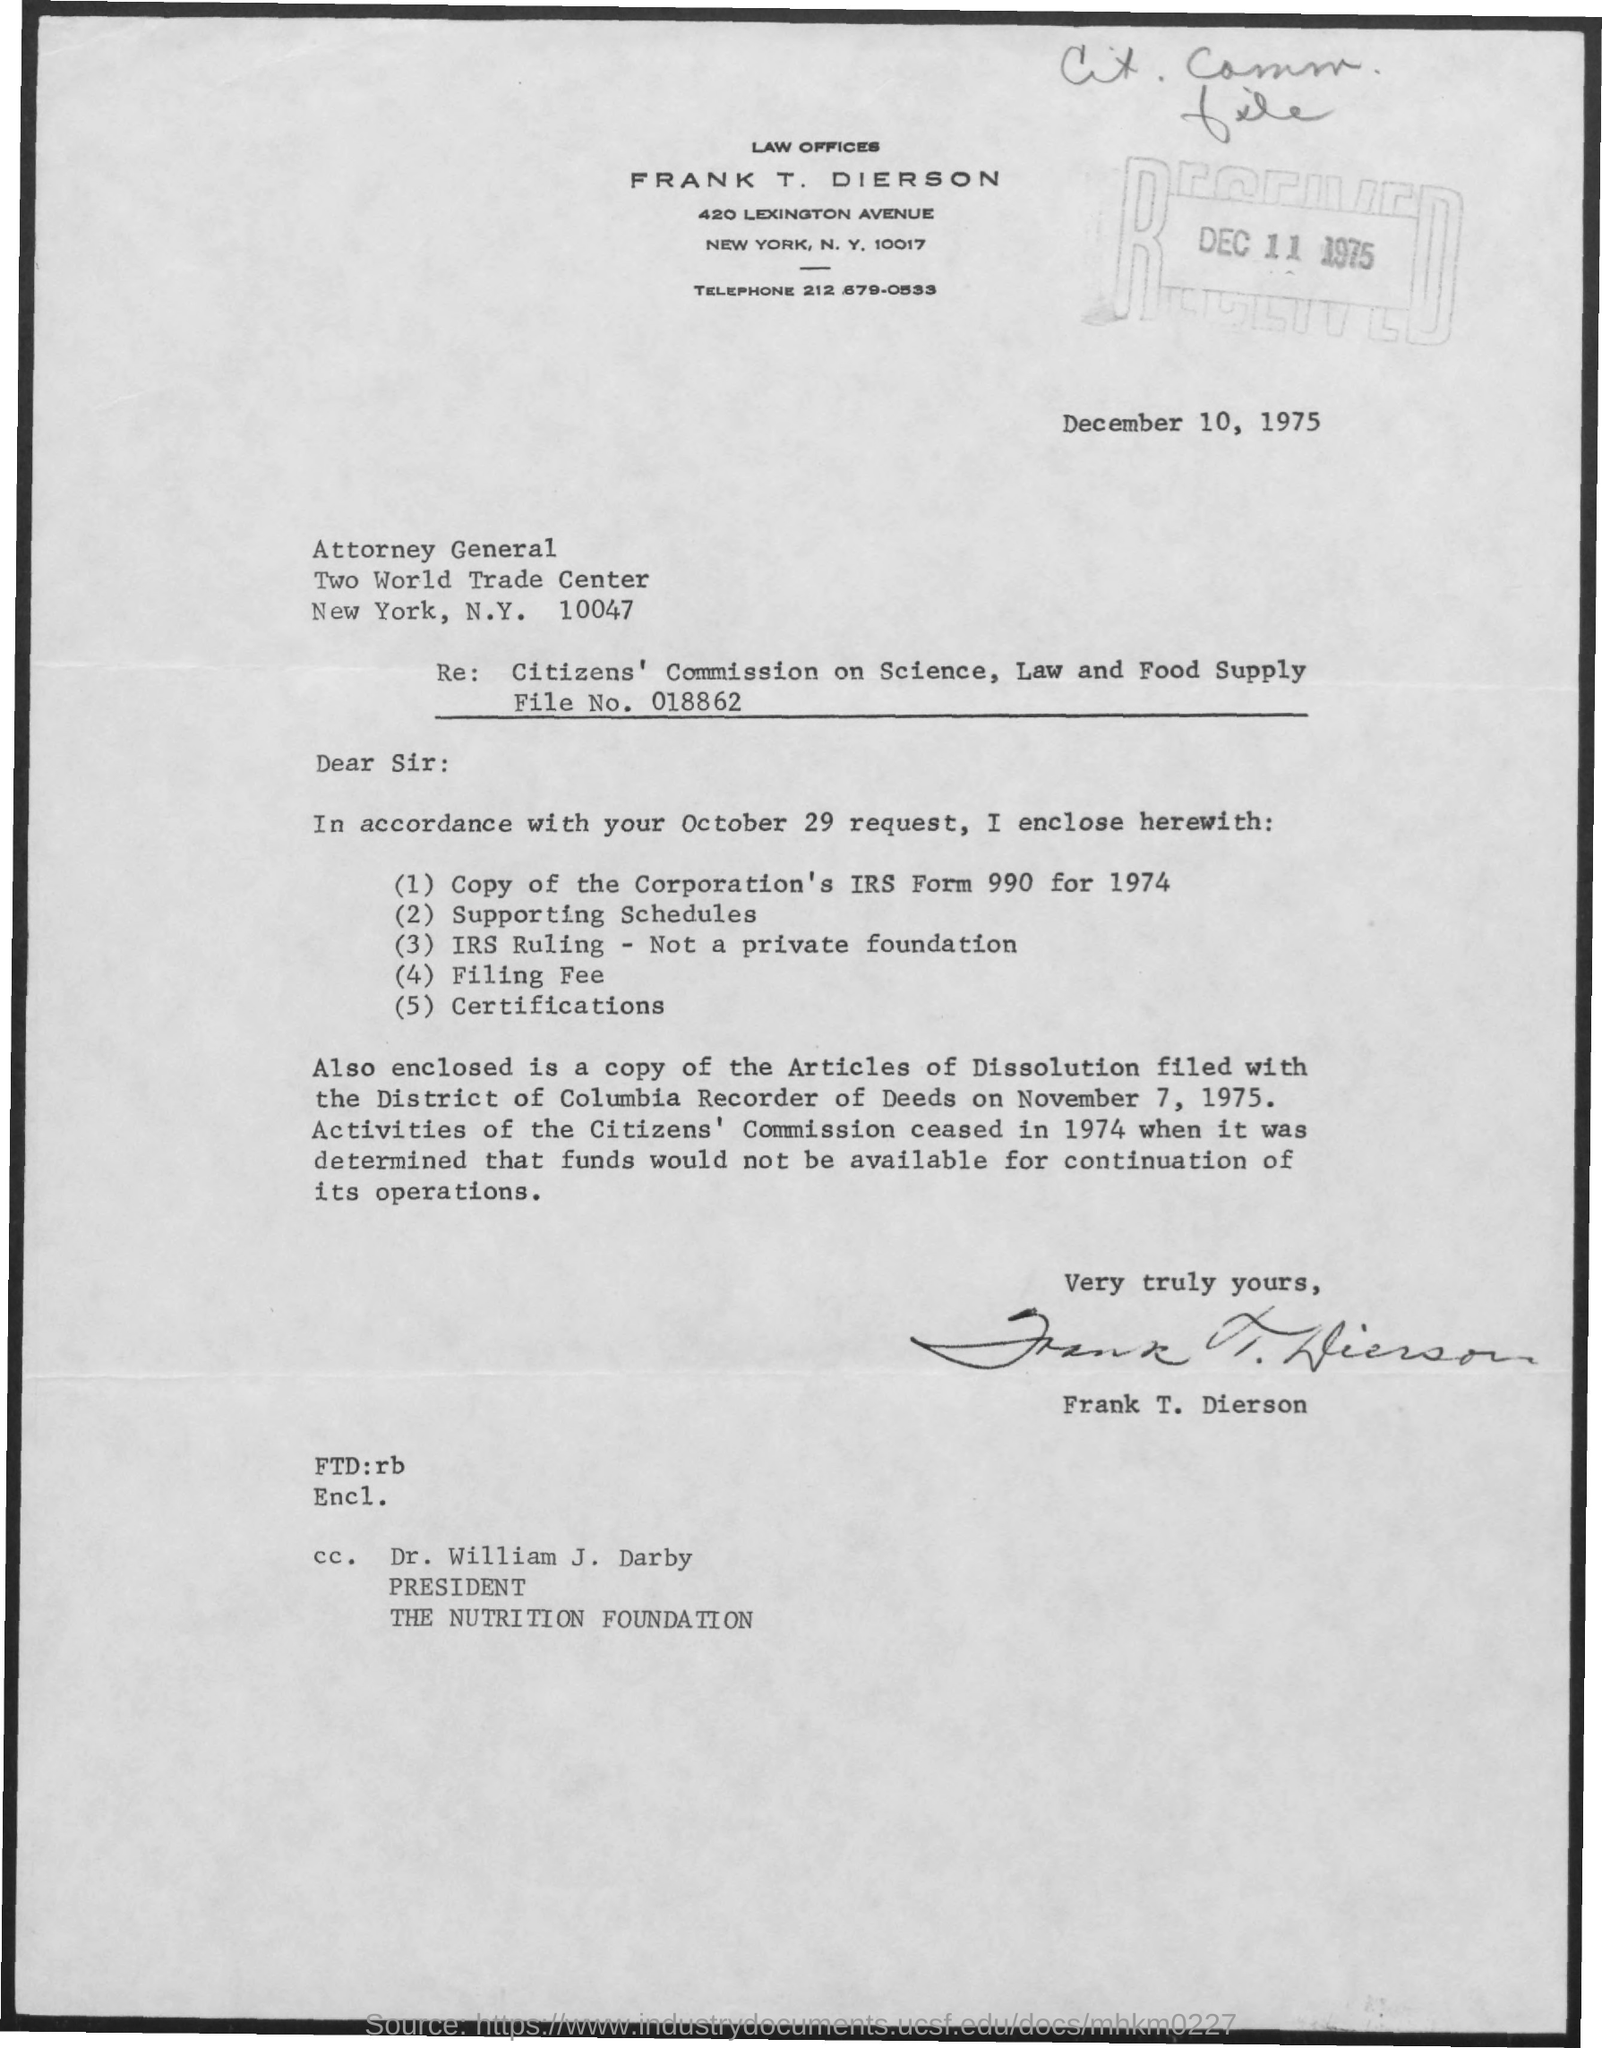Who is mentioned in the cc ?
Ensure brevity in your answer.  Dr. william J. Darby. What is the designation of dr. william j. darby?
Offer a terse response. President. This letter is written by whom ?
Your answer should be compact. Frank T. Dierson. What is the file no mentioned in the re :
Your answer should be very brief. File No. 018862. What is the telephone number mentioned ?
Offer a very short reply. 212 679-0533. 